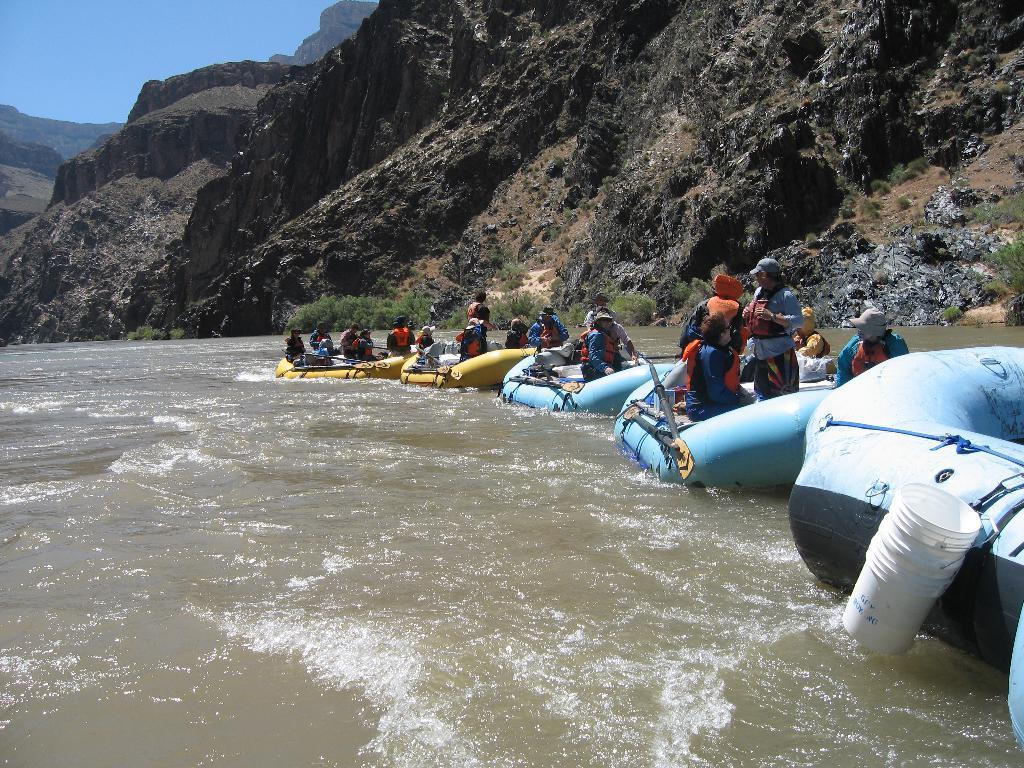In one or two sentences, can you explain what this image depicts? In this image we can see inflatable boats on the surface of water and people are present in the boats. Background of the image, mountains are there. At the left top of the image blue color sky is present. 